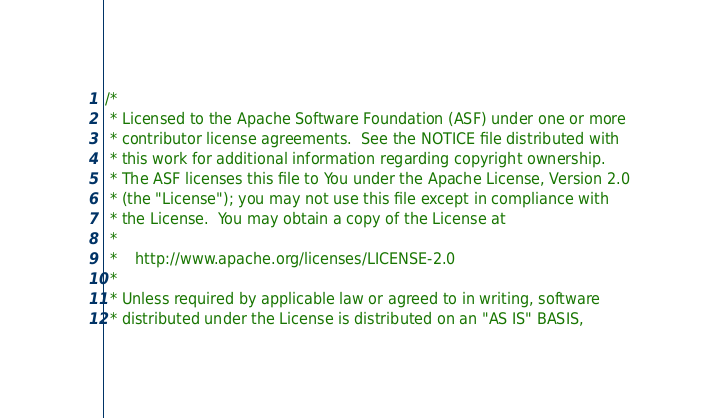<code> <loc_0><loc_0><loc_500><loc_500><_Scala_>/*
 * Licensed to the Apache Software Foundation (ASF) under one or more
 * contributor license agreements.  See the NOTICE file distributed with
 * this work for additional information regarding copyright ownership.
 * The ASF licenses this file to You under the Apache License, Version 2.0
 * (the "License"); you may not use this file except in compliance with
 * the License.  You may obtain a copy of the License at
 *
 *    http://www.apache.org/licenses/LICENSE-2.0
 *
 * Unless required by applicable law or agreed to in writing, software
 * distributed under the License is distributed on an "AS IS" BASIS,</code> 